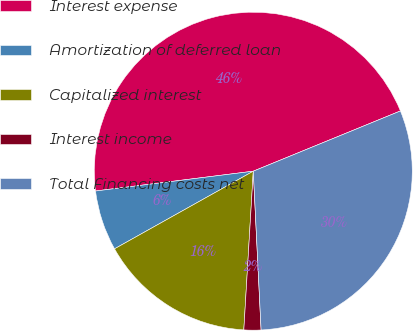Convert chart. <chart><loc_0><loc_0><loc_500><loc_500><pie_chart><fcel>Interest expense<fcel>Amortization of deferred loan<fcel>Capitalized interest<fcel>Interest income<fcel>Total Financing costs net<nl><fcel>45.8%<fcel>6.13%<fcel>15.93%<fcel>1.73%<fcel>30.4%<nl></chart> 